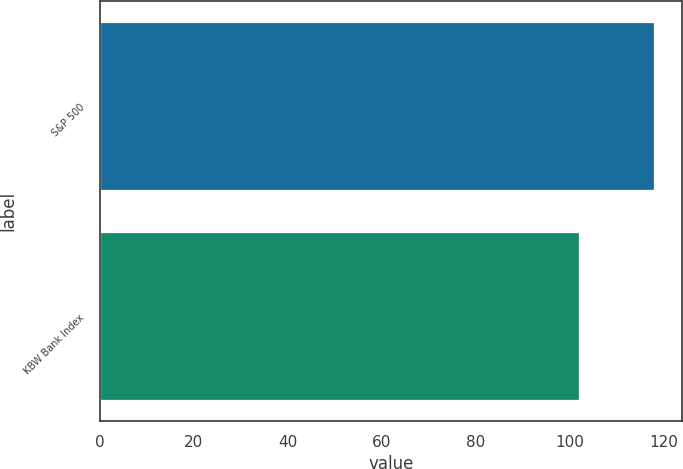<chart> <loc_0><loc_0><loc_500><loc_500><bar_chart><fcel>S&P 500<fcel>KBW Bank Index<nl><fcel>118<fcel>102<nl></chart> 